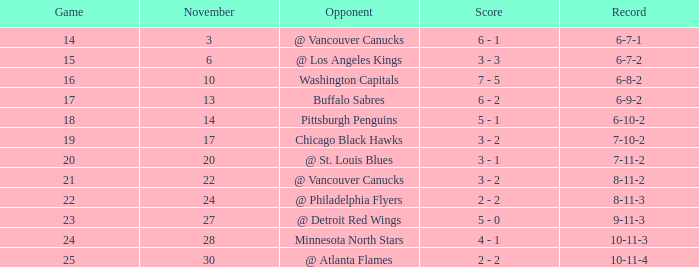Who is the opponent on november 24? @ Philadelphia Flyers. 